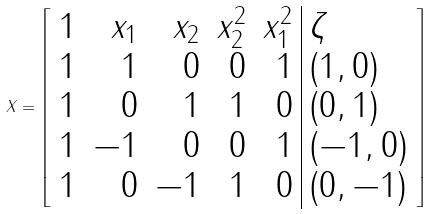Convert formula to latex. <formula><loc_0><loc_0><loc_500><loc_500>X = \left [ \begin{array} { r r r r r | l } 1 & x _ { 1 } & x _ { 2 } & x _ { 2 } ^ { 2 } & x _ { 1 } ^ { 2 } & \zeta \\ 1 & 1 & 0 & 0 & 1 & ( 1 , 0 ) \\ 1 & 0 & 1 & 1 & 0 & ( 0 , 1 ) \\ 1 & - 1 & 0 & 0 & 1 & ( - 1 , 0 ) \\ 1 & 0 & - 1 & 1 & 0 & ( 0 , - 1 ) \end{array} \right ]</formula> 